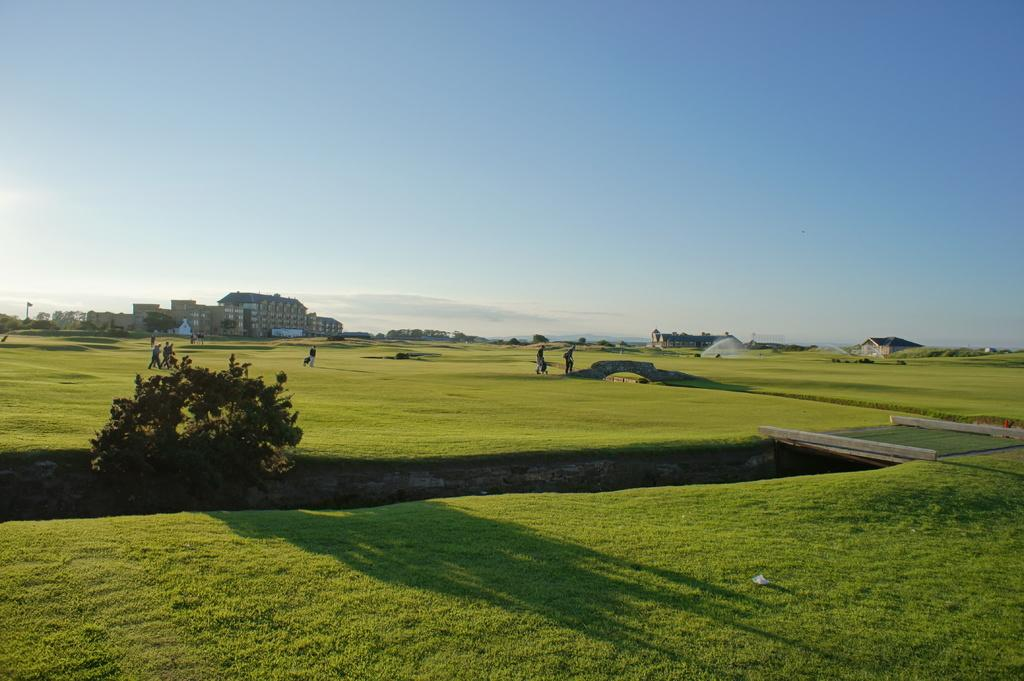How many people are in the image? There are people in the image, but the exact number is not specified. What type of terrain is visible in the image? There is grass on the ground in the image. What structures can be seen in the image? There are buildings in the image. What type of vegetation is present in the image? There are trees in the image. What else can be seen in the image besides people, grass, buildings, and trees? There are some objects in the image. What is visible in the background of the image? The sky is visible in the background of the image. What type of patch is being used to fix the robin's wing in the image? There is no robin or patch present in the image. 